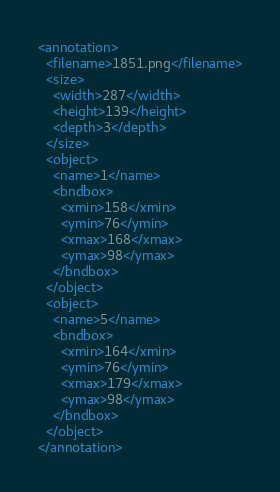<code> <loc_0><loc_0><loc_500><loc_500><_XML_><annotation>
  <filename>1851.png</filename>
  <size>
    <width>287</width>
    <height>139</height>
    <depth>3</depth>
  </size>
  <object>
    <name>1</name>
    <bndbox>
      <xmin>158</xmin>
      <ymin>76</ymin>
      <xmax>168</xmax>
      <ymax>98</ymax>
    </bndbox>
  </object>
  <object>
    <name>5</name>
    <bndbox>
      <xmin>164</xmin>
      <ymin>76</ymin>
      <xmax>179</xmax>
      <ymax>98</ymax>
    </bndbox>
  </object>
</annotation>
</code> 